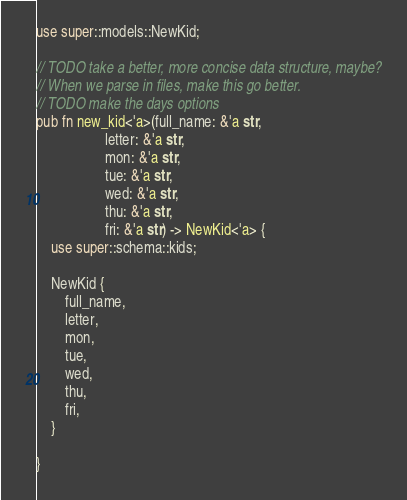<code> <loc_0><loc_0><loc_500><loc_500><_Rust_>use super::models::NewKid;

// TODO take a better, more concise data structure, maybe?
// When we parse in files, make this go better.
// TODO make the days options
pub fn new_kid<'a>(full_name: &'a str,
                   letter: &'a str,
                   mon: &'a str,
                   tue: &'a str,
                   wed: &'a str,
                   thu: &'a str,
                   fri: &'a str) -> NewKid<'a> {
    use super::schema::kids;

    NewKid {
        full_name,
        letter,
        mon,
        tue,
        wed,
        thu,
        fri,
    }

}
</code> 